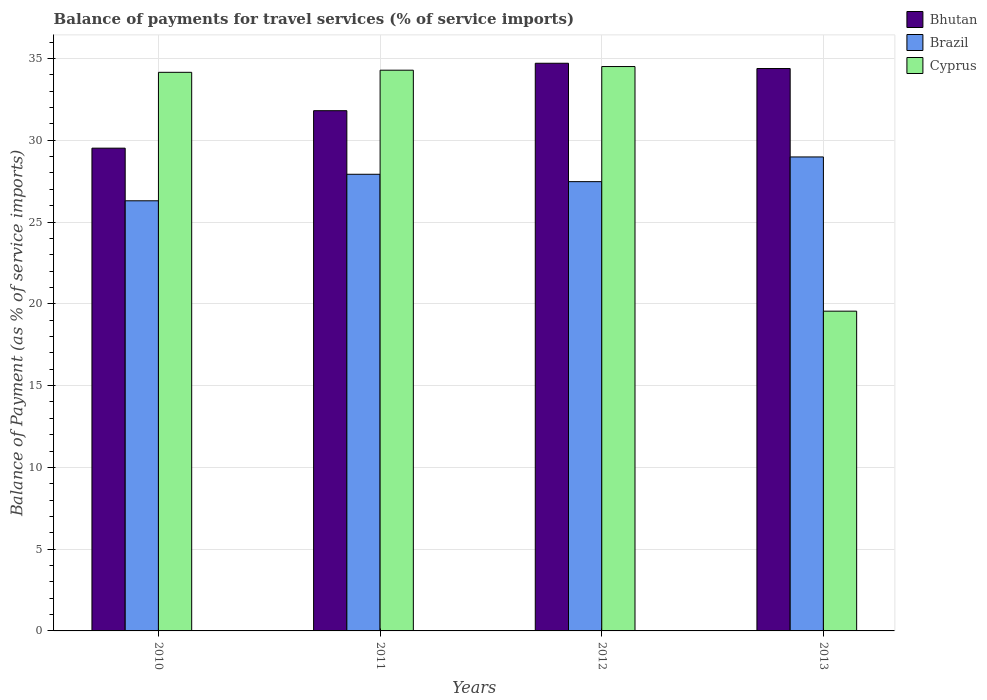How many different coloured bars are there?
Ensure brevity in your answer.  3. How many groups of bars are there?
Your answer should be very brief. 4. Are the number of bars on each tick of the X-axis equal?
Your answer should be very brief. Yes. What is the label of the 4th group of bars from the left?
Your response must be concise. 2013. In how many cases, is the number of bars for a given year not equal to the number of legend labels?
Give a very brief answer. 0. What is the balance of payments for travel services in Cyprus in 2013?
Your response must be concise. 19.55. Across all years, what is the maximum balance of payments for travel services in Bhutan?
Your answer should be compact. 34.71. Across all years, what is the minimum balance of payments for travel services in Cyprus?
Offer a very short reply. 19.55. In which year was the balance of payments for travel services in Brazil minimum?
Your answer should be compact. 2010. What is the total balance of payments for travel services in Brazil in the graph?
Provide a succinct answer. 110.67. What is the difference between the balance of payments for travel services in Bhutan in 2010 and that in 2012?
Offer a very short reply. -5.19. What is the difference between the balance of payments for travel services in Brazil in 2011 and the balance of payments for travel services in Bhutan in 2013?
Keep it short and to the point. -6.47. What is the average balance of payments for travel services in Brazil per year?
Your answer should be very brief. 27.67. In the year 2010, what is the difference between the balance of payments for travel services in Bhutan and balance of payments for travel services in Brazil?
Your answer should be compact. 3.22. What is the ratio of the balance of payments for travel services in Bhutan in 2011 to that in 2012?
Ensure brevity in your answer.  0.92. What is the difference between the highest and the second highest balance of payments for travel services in Bhutan?
Provide a succinct answer. 0.32. What is the difference between the highest and the lowest balance of payments for travel services in Brazil?
Make the answer very short. 2.68. In how many years, is the balance of payments for travel services in Cyprus greater than the average balance of payments for travel services in Cyprus taken over all years?
Your answer should be very brief. 3. What does the 3rd bar from the left in 2012 represents?
Provide a succinct answer. Cyprus. How many bars are there?
Your response must be concise. 12. Are the values on the major ticks of Y-axis written in scientific E-notation?
Ensure brevity in your answer.  No. Does the graph contain grids?
Make the answer very short. Yes. How many legend labels are there?
Provide a succinct answer. 3. How are the legend labels stacked?
Offer a very short reply. Vertical. What is the title of the graph?
Offer a terse response. Balance of payments for travel services (% of service imports). What is the label or title of the X-axis?
Provide a short and direct response. Years. What is the label or title of the Y-axis?
Offer a very short reply. Balance of Payment (as % of service imports). What is the Balance of Payment (as % of service imports) of Bhutan in 2010?
Give a very brief answer. 29.52. What is the Balance of Payment (as % of service imports) in Brazil in 2010?
Offer a terse response. 26.3. What is the Balance of Payment (as % of service imports) in Cyprus in 2010?
Ensure brevity in your answer.  34.15. What is the Balance of Payment (as % of service imports) in Bhutan in 2011?
Your answer should be very brief. 31.81. What is the Balance of Payment (as % of service imports) in Brazil in 2011?
Provide a succinct answer. 27.92. What is the Balance of Payment (as % of service imports) of Cyprus in 2011?
Provide a short and direct response. 34.28. What is the Balance of Payment (as % of service imports) in Bhutan in 2012?
Provide a short and direct response. 34.71. What is the Balance of Payment (as % of service imports) in Brazil in 2012?
Make the answer very short. 27.47. What is the Balance of Payment (as % of service imports) of Cyprus in 2012?
Provide a succinct answer. 34.51. What is the Balance of Payment (as % of service imports) in Bhutan in 2013?
Offer a terse response. 34.39. What is the Balance of Payment (as % of service imports) in Brazil in 2013?
Your answer should be compact. 28.98. What is the Balance of Payment (as % of service imports) in Cyprus in 2013?
Offer a very short reply. 19.55. Across all years, what is the maximum Balance of Payment (as % of service imports) of Bhutan?
Your answer should be very brief. 34.71. Across all years, what is the maximum Balance of Payment (as % of service imports) of Brazil?
Offer a terse response. 28.98. Across all years, what is the maximum Balance of Payment (as % of service imports) in Cyprus?
Offer a terse response. 34.51. Across all years, what is the minimum Balance of Payment (as % of service imports) in Bhutan?
Provide a short and direct response. 29.52. Across all years, what is the minimum Balance of Payment (as % of service imports) in Brazil?
Provide a short and direct response. 26.3. Across all years, what is the minimum Balance of Payment (as % of service imports) in Cyprus?
Your answer should be very brief. 19.55. What is the total Balance of Payment (as % of service imports) in Bhutan in the graph?
Give a very brief answer. 130.42. What is the total Balance of Payment (as % of service imports) of Brazil in the graph?
Offer a very short reply. 110.67. What is the total Balance of Payment (as % of service imports) in Cyprus in the graph?
Offer a very short reply. 122.49. What is the difference between the Balance of Payment (as % of service imports) in Bhutan in 2010 and that in 2011?
Your answer should be compact. -2.29. What is the difference between the Balance of Payment (as % of service imports) in Brazil in 2010 and that in 2011?
Provide a short and direct response. -1.62. What is the difference between the Balance of Payment (as % of service imports) of Cyprus in 2010 and that in 2011?
Offer a very short reply. -0.13. What is the difference between the Balance of Payment (as % of service imports) of Bhutan in 2010 and that in 2012?
Offer a very short reply. -5.19. What is the difference between the Balance of Payment (as % of service imports) of Brazil in 2010 and that in 2012?
Your answer should be compact. -1.17. What is the difference between the Balance of Payment (as % of service imports) of Cyprus in 2010 and that in 2012?
Provide a short and direct response. -0.35. What is the difference between the Balance of Payment (as % of service imports) of Bhutan in 2010 and that in 2013?
Offer a terse response. -4.87. What is the difference between the Balance of Payment (as % of service imports) of Brazil in 2010 and that in 2013?
Make the answer very short. -2.68. What is the difference between the Balance of Payment (as % of service imports) in Cyprus in 2010 and that in 2013?
Provide a succinct answer. 14.6. What is the difference between the Balance of Payment (as % of service imports) in Brazil in 2011 and that in 2012?
Make the answer very short. 0.45. What is the difference between the Balance of Payment (as % of service imports) in Cyprus in 2011 and that in 2012?
Provide a short and direct response. -0.22. What is the difference between the Balance of Payment (as % of service imports) in Bhutan in 2011 and that in 2013?
Your answer should be compact. -2.58. What is the difference between the Balance of Payment (as % of service imports) of Brazil in 2011 and that in 2013?
Provide a succinct answer. -1.06. What is the difference between the Balance of Payment (as % of service imports) in Cyprus in 2011 and that in 2013?
Offer a terse response. 14.73. What is the difference between the Balance of Payment (as % of service imports) in Bhutan in 2012 and that in 2013?
Ensure brevity in your answer.  0.32. What is the difference between the Balance of Payment (as % of service imports) in Brazil in 2012 and that in 2013?
Your answer should be compact. -1.51. What is the difference between the Balance of Payment (as % of service imports) in Cyprus in 2012 and that in 2013?
Provide a short and direct response. 14.96. What is the difference between the Balance of Payment (as % of service imports) of Bhutan in 2010 and the Balance of Payment (as % of service imports) of Brazil in 2011?
Offer a very short reply. 1.6. What is the difference between the Balance of Payment (as % of service imports) in Bhutan in 2010 and the Balance of Payment (as % of service imports) in Cyprus in 2011?
Keep it short and to the point. -4.77. What is the difference between the Balance of Payment (as % of service imports) of Brazil in 2010 and the Balance of Payment (as % of service imports) of Cyprus in 2011?
Offer a terse response. -7.98. What is the difference between the Balance of Payment (as % of service imports) in Bhutan in 2010 and the Balance of Payment (as % of service imports) in Brazil in 2012?
Give a very brief answer. 2.05. What is the difference between the Balance of Payment (as % of service imports) in Bhutan in 2010 and the Balance of Payment (as % of service imports) in Cyprus in 2012?
Offer a very short reply. -4.99. What is the difference between the Balance of Payment (as % of service imports) of Brazil in 2010 and the Balance of Payment (as % of service imports) of Cyprus in 2012?
Offer a very short reply. -8.21. What is the difference between the Balance of Payment (as % of service imports) in Bhutan in 2010 and the Balance of Payment (as % of service imports) in Brazil in 2013?
Your answer should be compact. 0.54. What is the difference between the Balance of Payment (as % of service imports) in Bhutan in 2010 and the Balance of Payment (as % of service imports) in Cyprus in 2013?
Your answer should be compact. 9.97. What is the difference between the Balance of Payment (as % of service imports) of Brazil in 2010 and the Balance of Payment (as % of service imports) of Cyprus in 2013?
Keep it short and to the point. 6.75. What is the difference between the Balance of Payment (as % of service imports) in Bhutan in 2011 and the Balance of Payment (as % of service imports) in Brazil in 2012?
Ensure brevity in your answer.  4.34. What is the difference between the Balance of Payment (as % of service imports) in Bhutan in 2011 and the Balance of Payment (as % of service imports) in Cyprus in 2012?
Provide a short and direct response. -2.7. What is the difference between the Balance of Payment (as % of service imports) in Brazil in 2011 and the Balance of Payment (as % of service imports) in Cyprus in 2012?
Your response must be concise. -6.59. What is the difference between the Balance of Payment (as % of service imports) in Bhutan in 2011 and the Balance of Payment (as % of service imports) in Brazil in 2013?
Keep it short and to the point. 2.83. What is the difference between the Balance of Payment (as % of service imports) in Bhutan in 2011 and the Balance of Payment (as % of service imports) in Cyprus in 2013?
Your response must be concise. 12.26. What is the difference between the Balance of Payment (as % of service imports) in Brazil in 2011 and the Balance of Payment (as % of service imports) in Cyprus in 2013?
Provide a succinct answer. 8.37. What is the difference between the Balance of Payment (as % of service imports) of Bhutan in 2012 and the Balance of Payment (as % of service imports) of Brazil in 2013?
Your answer should be very brief. 5.73. What is the difference between the Balance of Payment (as % of service imports) in Bhutan in 2012 and the Balance of Payment (as % of service imports) in Cyprus in 2013?
Your response must be concise. 15.16. What is the difference between the Balance of Payment (as % of service imports) in Brazil in 2012 and the Balance of Payment (as % of service imports) in Cyprus in 2013?
Provide a short and direct response. 7.92. What is the average Balance of Payment (as % of service imports) of Bhutan per year?
Keep it short and to the point. 32.6. What is the average Balance of Payment (as % of service imports) in Brazil per year?
Your response must be concise. 27.67. What is the average Balance of Payment (as % of service imports) of Cyprus per year?
Offer a terse response. 30.62. In the year 2010, what is the difference between the Balance of Payment (as % of service imports) in Bhutan and Balance of Payment (as % of service imports) in Brazil?
Offer a very short reply. 3.22. In the year 2010, what is the difference between the Balance of Payment (as % of service imports) in Bhutan and Balance of Payment (as % of service imports) in Cyprus?
Your answer should be compact. -4.64. In the year 2010, what is the difference between the Balance of Payment (as % of service imports) of Brazil and Balance of Payment (as % of service imports) of Cyprus?
Offer a very short reply. -7.85. In the year 2011, what is the difference between the Balance of Payment (as % of service imports) of Bhutan and Balance of Payment (as % of service imports) of Brazil?
Provide a succinct answer. 3.89. In the year 2011, what is the difference between the Balance of Payment (as % of service imports) of Bhutan and Balance of Payment (as % of service imports) of Cyprus?
Give a very brief answer. -2.48. In the year 2011, what is the difference between the Balance of Payment (as % of service imports) in Brazil and Balance of Payment (as % of service imports) in Cyprus?
Your response must be concise. -6.36. In the year 2012, what is the difference between the Balance of Payment (as % of service imports) of Bhutan and Balance of Payment (as % of service imports) of Brazil?
Ensure brevity in your answer.  7.24. In the year 2012, what is the difference between the Balance of Payment (as % of service imports) in Bhutan and Balance of Payment (as % of service imports) in Cyprus?
Your answer should be very brief. 0.2. In the year 2012, what is the difference between the Balance of Payment (as % of service imports) in Brazil and Balance of Payment (as % of service imports) in Cyprus?
Make the answer very short. -7.04. In the year 2013, what is the difference between the Balance of Payment (as % of service imports) in Bhutan and Balance of Payment (as % of service imports) in Brazil?
Give a very brief answer. 5.41. In the year 2013, what is the difference between the Balance of Payment (as % of service imports) of Bhutan and Balance of Payment (as % of service imports) of Cyprus?
Provide a succinct answer. 14.84. In the year 2013, what is the difference between the Balance of Payment (as % of service imports) in Brazil and Balance of Payment (as % of service imports) in Cyprus?
Give a very brief answer. 9.43. What is the ratio of the Balance of Payment (as % of service imports) of Bhutan in 2010 to that in 2011?
Your answer should be very brief. 0.93. What is the ratio of the Balance of Payment (as % of service imports) in Brazil in 2010 to that in 2011?
Provide a succinct answer. 0.94. What is the ratio of the Balance of Payment (as % of service imports) of Bhutan in 2010 to that in 2012?
Provide a succinct answer. 0.85. What is the ratio of the Balance of Payment (as % of service imports) in Brazil in 2010 to that in 2012?
Make the answer very short. 0.96. What is the ratio of the Balance of Payment (as % of service imports) in Cyprus in 2010 to that in 2012?
Your response must be concise. 0.99. What is the ratio of the Balance of Payment (as % of service imports) of Bhutan in 2010 to that in 2013?
Provide a succinct answer. 0.86. What is the ratio of the Balance of Payment (as % of service imports) in Brazil in 2010 to that in 2013?
Give a very brief answer. 0.91. What is the ratio of the Balance of Payment (as % of service imports) of Cyprus in 2010 to that in 2013?
Offer a very short reply. 1.75. What is the ratio of the Balance of Payment (as % of service imports) of Bhutan in 2011 to that in 2012?
Keep it short and to the point. 0.92. What is the ratio of the Balance of Payment (as % of service imports) in Brazil in 2011 to that in 2012?
Offer a very short reply. 1.02. What is the ratio of the Balance of Payment (as % of service imports) in Bhutan in 2011 to that in 2013?
Offer a terse response. 0.93. What is the ratio of the Balance of Payment (as % of service imports) of Brazil in 2011 to that in 2013?
Your answer should be very brief. 0.96. What is the ratio of the Balance of Payment (as % of service imports) of Cyprus in 2011 to that in 2013?
Make the answer very short. 1.75. What is the ratio of the Balance of Payment (as % of service imports) of Bhutan in 2012 to that in 2013?
Your answer should be compact. 1.01. What is the ratio of the Balance of Payment (as % of service imports) of Brazil in 2012 to that in 2013?
Keep it short and to the point. 0.95. What is the ratio of the Balance of Payment (as % of service imports) of Cyprus in 2012 to that in 2013?
Your response must be concise. 1.76. What is the difference between the highest and the second highest Balance of Payment (as % of service imports) of Bhutan?
Make the answer very short. 0.32. What is the difference between the highest and the second highest Balance of Payment (as % of service imports) of Brazil?
Offer a terse response. 1.06. What is the difference between the highest and the second highest Balance of Payment (as % of service imports) of Cyprus?
Keep it short and to the point. 0.22. What is the difference between the highest and the lowest Balance of Payment (as % of service imports) of Bhutan?
Provide a short and direct response. 5.19. What is the difference between the highest and the lowest Balance of Payment (as % of service imports) in Brazil?
Provide a short and direct response. 2.68. What is the difference between the highest and the lowest Balance of Payment (as % of service imports) of Cyprus?
Provide a succinct answer. 14.96. 